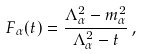Convert formula to latex. <formula><loc_0><loc_0><loc_500><loc_500>F _ { \alpha } ( t ) = \frac { \Lambda _ { \alpha } ^ { 2 } - m _ { \alpha } ^ { 2 } } { \Lambda _ { \alpha } ^ { 2 } - t } \, ,</formula> 